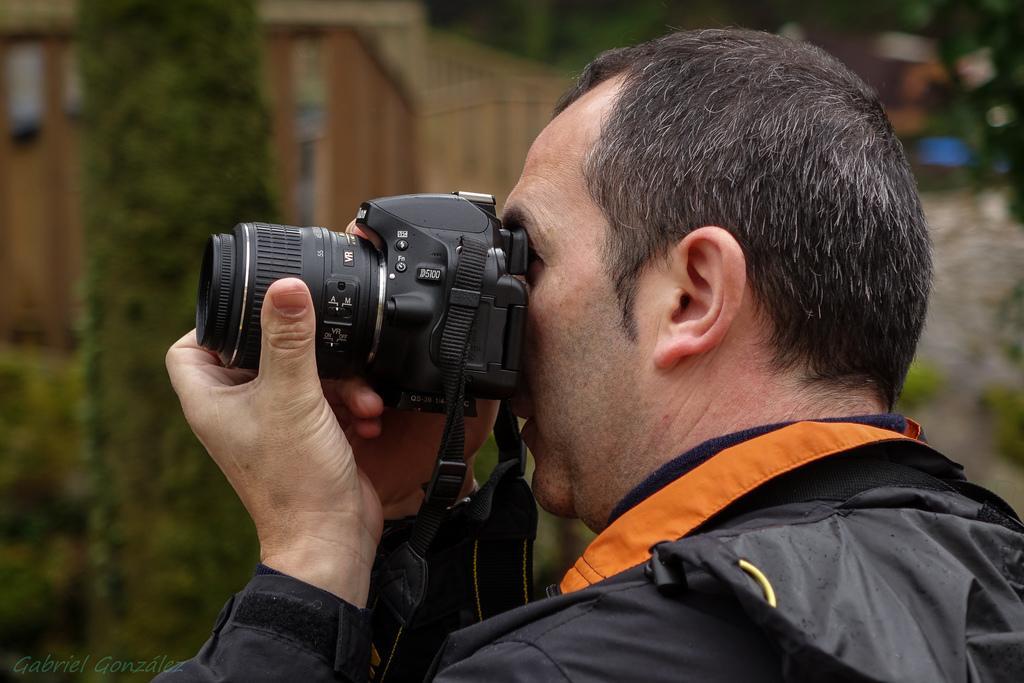Could you give a brief overview of what you see in this image? In this picture a man is holding a camera is clicking picture. he is wearing a black jacket. in the background there is building and trees. 